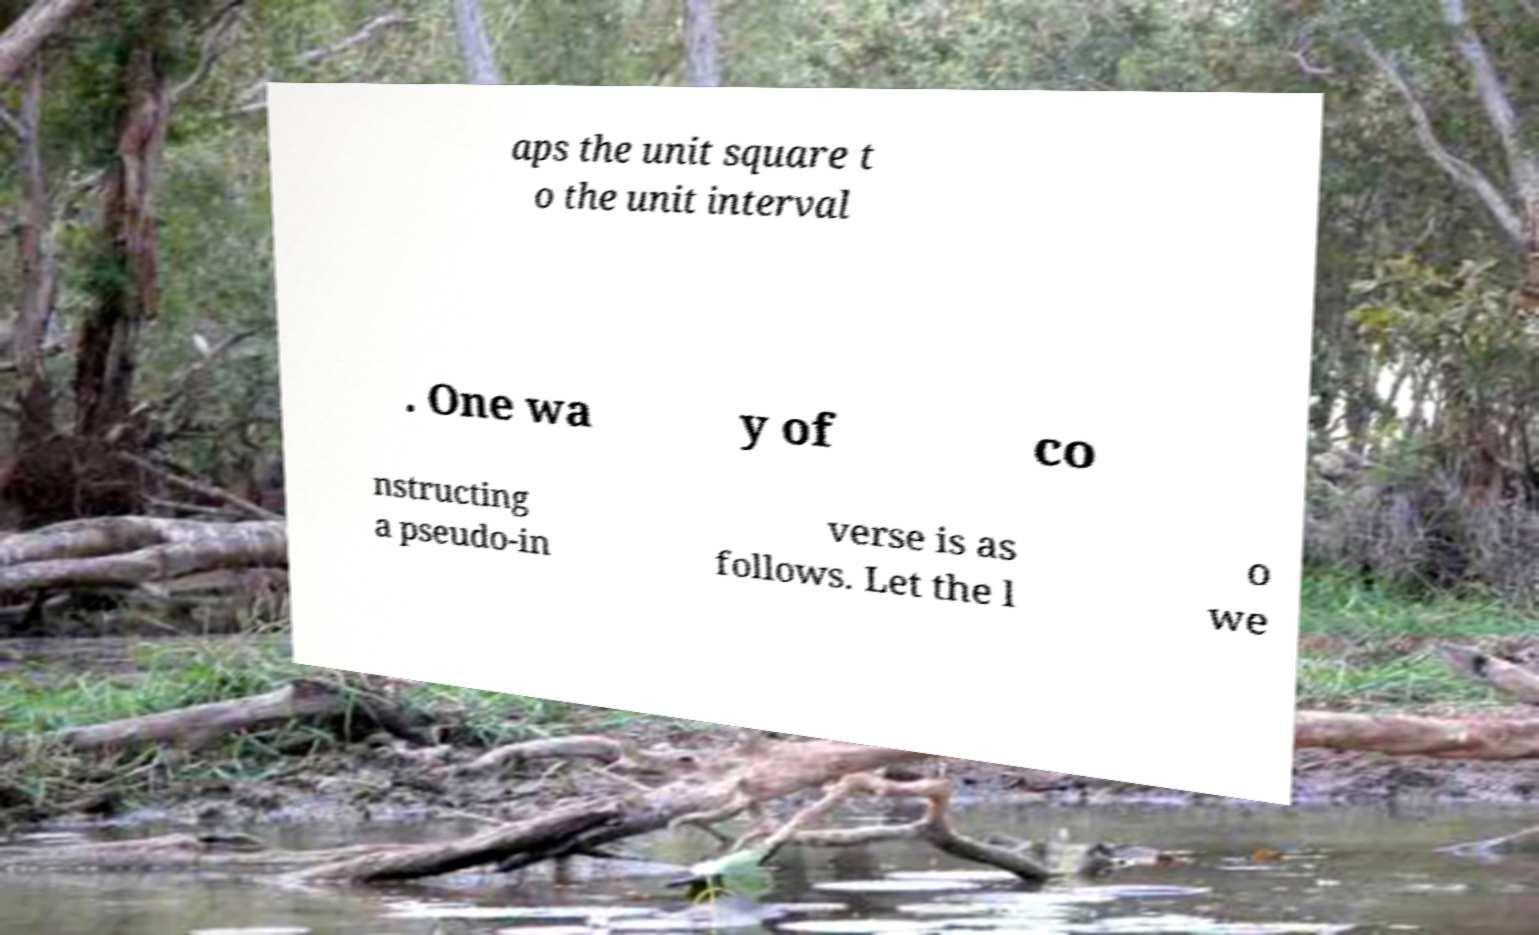I need the written content from this picture converted into text. Can you do that? aps the unit square t o the unit interval . One wa y of co nstructing a pseudo-in verse is as follows. Let the l o we 